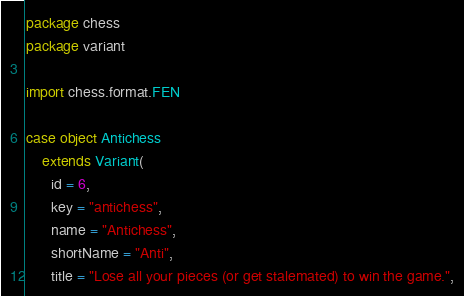<code> <loc_0><loc_0><loc_500><loc_500><_Scala_>package chess
package variant

import chess.format.FEN

case object Antichess
    extends Variant(
      id = 6,
      key = "antichess",
      name = "Antichess",
      shortName = "Anti",
      title = "Lose all your pieces (or get stalemated) to win the game.",</code> 